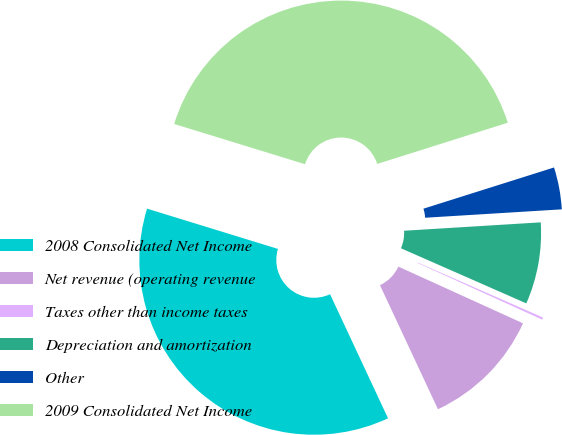Convert chart to OTSL. <chart><loc_0><loc_0><loc_500><loc_500><pie_chart><fcel>2008 Consolidated Net Income<fcel>Net revenue (operating revenue<fcel>Taxes other than income taxes<fcel>Depreciation and amortization<fcel>Other<fcel>2009 Consolidated Net Income<nl><fcel>36.71%<fcel>11.25%<fcel>0.2%<fcel>7.57%<fcel>3.89%<fcel>40.39%<nl></chart> 